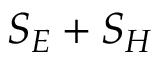Convert formula to latex. <formula><loc_0><loc_0><loc_500><loc_500>S _ { E } + S _ { H }</formula> 